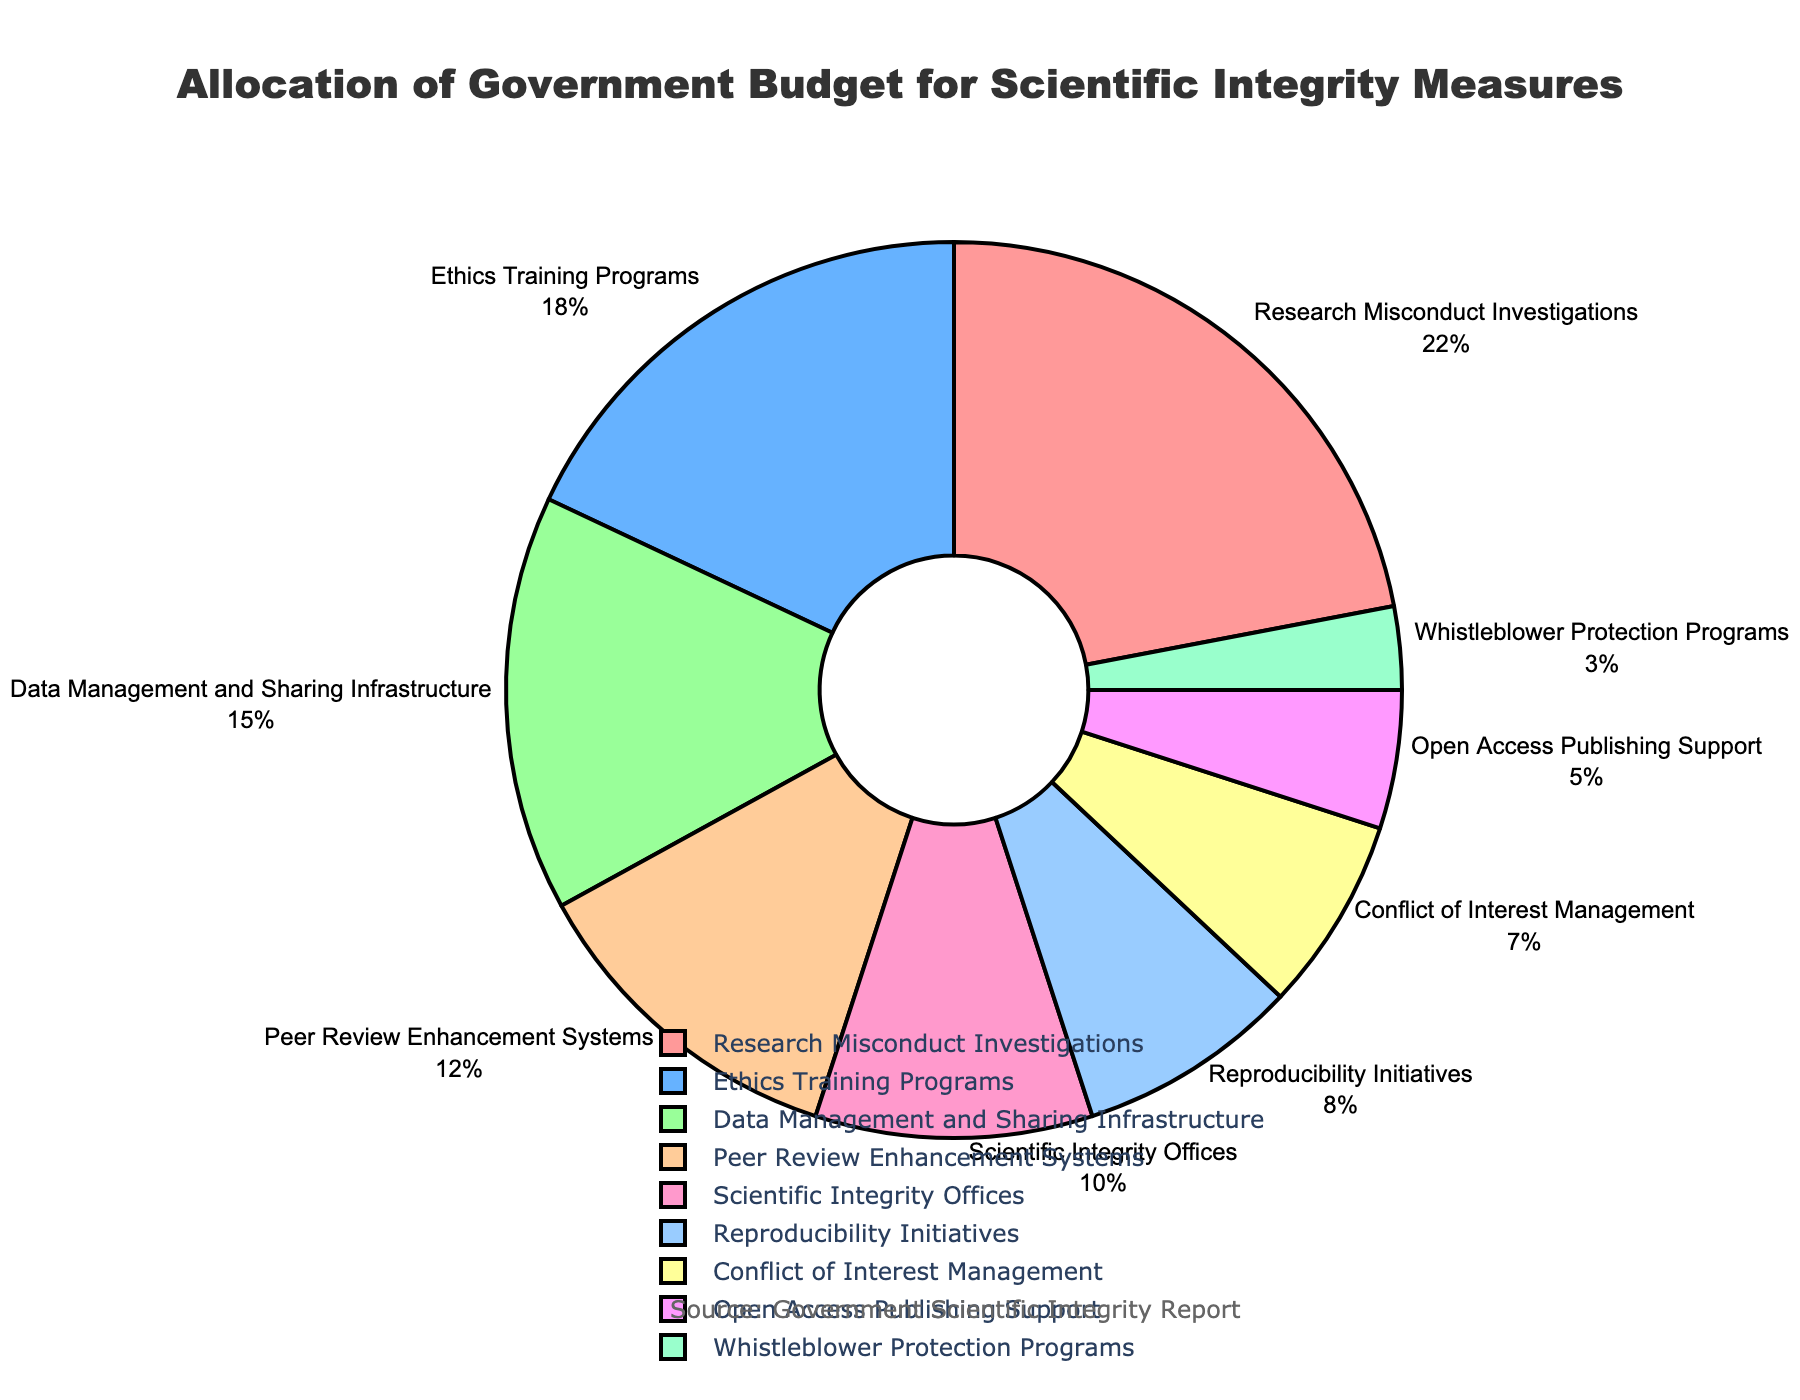What percentage of the budget is allocated to the top three categories combined? The top three categories are "Research Misconduct Investigations" (22%), "Ethics Training Programs" (18%), and "Data Management and Sharing Infrastructure" (15%). Summing these percentages gives 22 + 18 + 15 = 55.
Answer: 55% Which category receives less funding: Reproducibility Initiatives or Whistleblower Protection Programs? "Reproducibility Initiatives" receive 8% of the budget, while "Whistleblower Protection Programs" receive 3%. Since 8% is greater than 3%, "Whistleblower Protection Programs" receive less funding.
Answer: Whistleblower Protection Programs What is the combined budget allocation for categories with more than 10% allocation each? Categories with more than 10% allocation are "Research Misconduct Investigations" (22%), "Ethics Training Programs" (18%), "Data Management and Sharing Infrastructure" (15%), and "Peer Review Enhancement Systems" (12%). Summing these gives 22 + 18 + 15 + 12 = 67.
Answer: 67% Which category has the lowest budget allocation and what is its proportion? "Whistleblower Protection Programs" has the lowest budget allocation with 3%. This can be observed from the chart where it has the smallest segment.
Answer: Whistleblower Protection Programs, 3% Between "Conflict of Interest Management" and "Ethics Training Programs," which category has a higher budget allocation, and by how much? "Conflict of Interest Management" receives 7% while "Ethics Training Programs" receives 18%. The difference is 18 - 7 = 11.
Answer: Ethics Training Programs, 11% Which categories together constitute exactly 33% of the total budget? The categories "Scientific Integrity Offices" (10%), "Reproducibility Initiatives" (8%), "Conflict of Interest Management" (7%), "Open Access Publishing Support" (5%), and "Whistleblower Protection Programs" (3%) together make up 10 + 8 + 7 + 5 + 3 = 33%.
Answer: Scientific Integrity Offices, Reproducibility Initiatives, Conflict of Interest Management, Open Access Publishing Support, Whistleblower Protection Programs What is the second largest category in the budget allocation? The category "Ethics Training Programs" has the second largest budget allocation with 18%, the largest being "Research Misconduct Investigations" with 22%.
Answer: Ethics Training Programs 